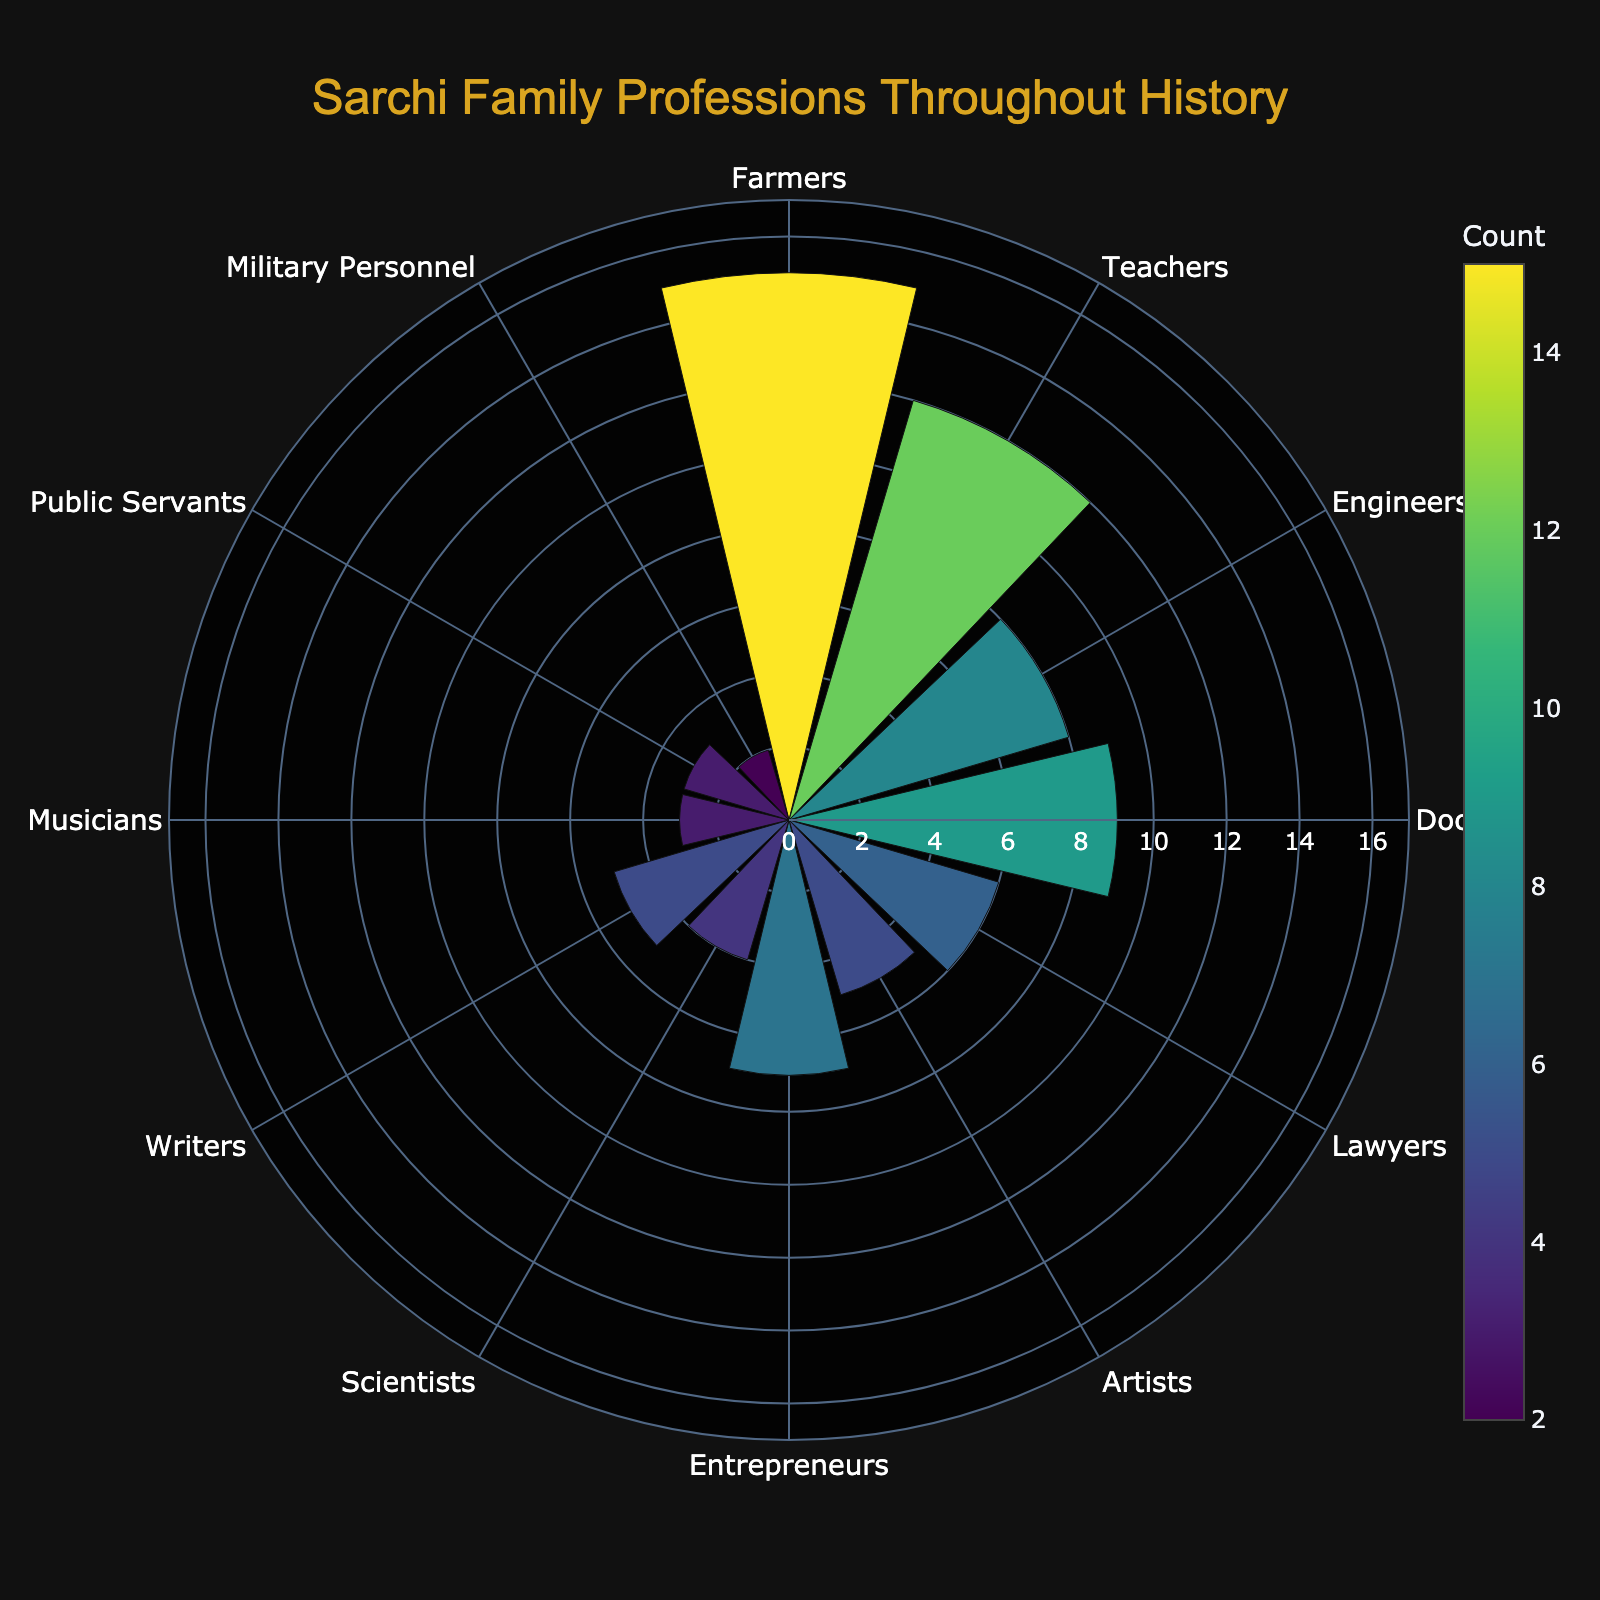what is the title of the figure? The title is usually prominently displayed at the top of the figure. In this case, it reads "Sarchi Family Professions Throughout History"
Answer: Sarchi Family Professions Throughout History How many different professions are represented in the chart? By looking at the number of segments in the polar area chart, we can count the different professions. Each profession has its own segment.
Answer: 12 Which profession has the highest count in the Sarchi family? By identifying the largest segment on the polar area chart, we see that "Farmers" has the highest count.
Answer: Farmers Which profession has the lowest count in the Sarchi family? By identifying the smallest segment on the polar area chart, we see that "Military Personnel" has the lowest count.
Answer: Military Personnel How many members of the Sarchi family are Teachers? By hovering over or looking at the segment labeled "Teachers," we can see that the count is 12.
Answer: 12 What is the combined count of Doctors and Lawyers in the Sarchi family? Add the counts for "Doctors" and "Lawyers" together: Doctors (9) + Lawyers (6) = 15.
Answer: 15 How does the count of Engineers compare to that of Musicians? By comparing the sizes of the segments for "Engineers" and "Musicians," we see that Engineers have a higher count than Musicians (8 vs 3).
Answer: Engineers have a higher count What colors are used to represent the different counts in the polar area chart? The chart uses a Viridis colorscale, which generally includes shades ranging from yellow to green to blue.
Answer: yellow, green, blue How many more Farmers are there compared to Entrepreneurs? Subtract the count of Entrepreneurs from Farmers: Farmers (15) - Entrepreneurs (7) = 8.
Answer: 8 What is the average count of public servants, military personnel, and musicians? Add the counts together and divide by the number of professions: (Public Servants 3 + Military Personnel 2 + Musicians 3) / 3 = 2.67.
Answer: 2.67 